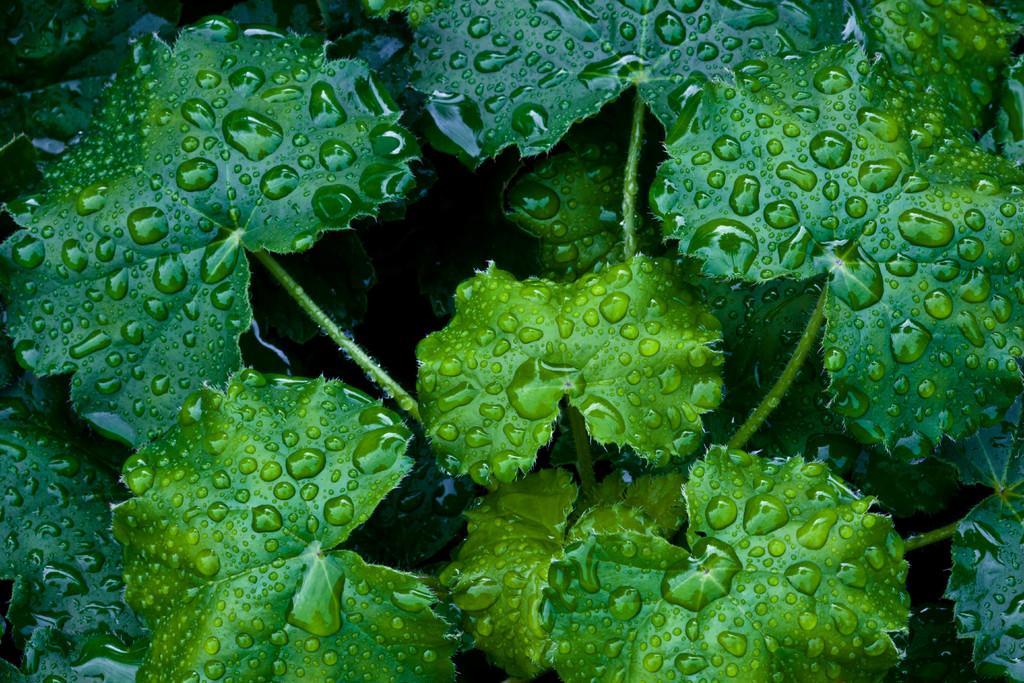Could you give a brief overview of what you see in this image? This is a zoomed in picture. In the foreground we can see the green leaves and the stems of the plants and we can see the droplets of water on the leaves. 